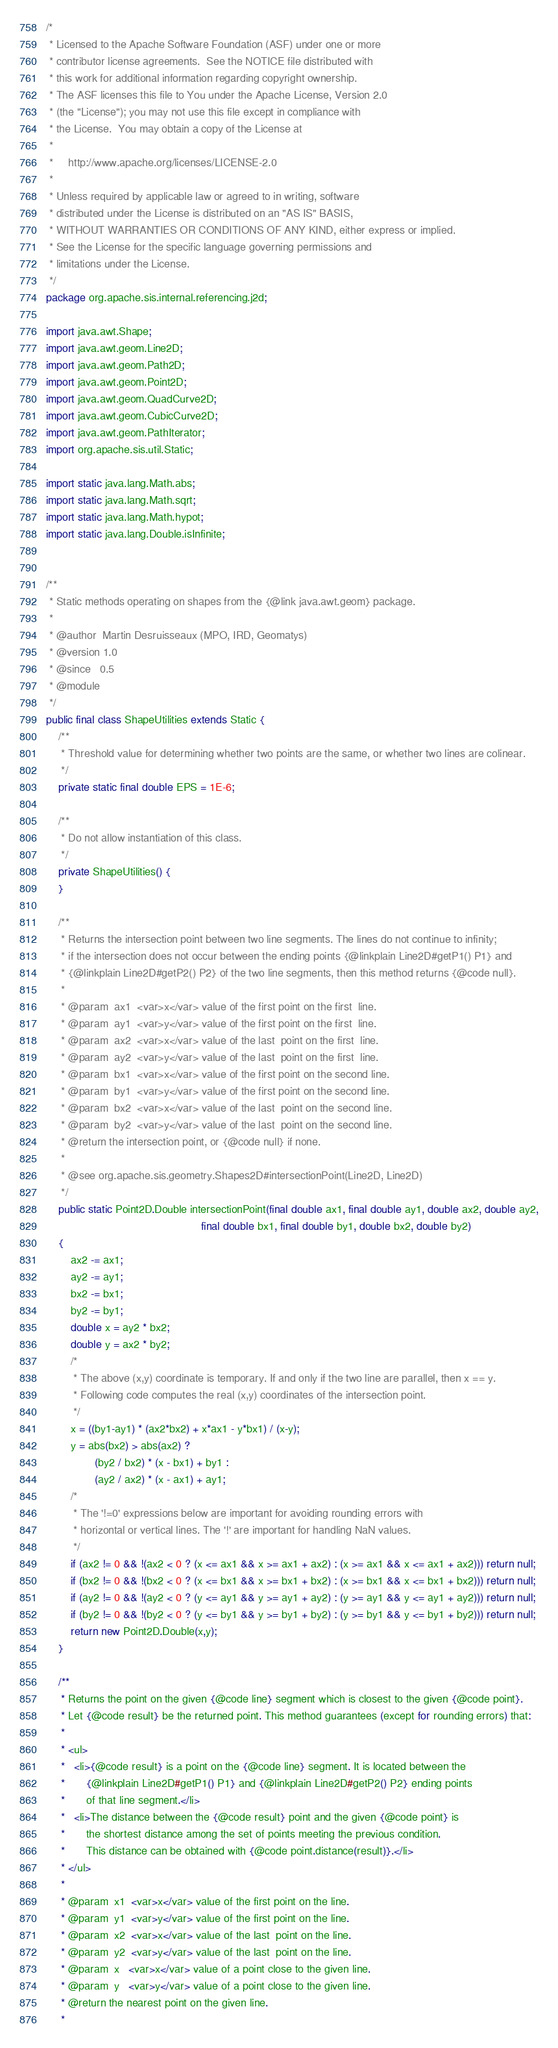<code> <loc_0><loc_0><loc_500><loc_500><_Java_>/*
 * Licensed to the Apache Software Foundation (ASF) under one or more
 * contributor license agreements.  See the NOTICE file distributed with
 * this work for additional information regarding copyright ownership.
 * The ASF licenses this file to You under the Apache License, Version 2.0
 * (the "License"); you may not use this file except in compliance with
 * the License.  You may obtain a copy of the License at
 *
 *     http://www.apache.org/licenses/LICENSE-2.0
 *
 * Unless required by applicable law or agreed to in writing, software
 * distributed under the License is distributed on an "AS IS" BASIS,
 * WITHOUT WARRANTIES OR CONDITIONS OF ANY KIND, either express or implied.
 * See the License for the specific language governing permissions and
 * limitations under the License.
 */
package org.apache.sis.internal.referencing.j2d;

import java.awt.Shape;
import java.awt.geom.Line2D;
import java.awt.geom.Path2D;
import java.awt.geom.Point2D;
import java.awt.geom.QuadCurve2D;
import java.awt.geom.CubicCurve2D;
import java.awt.geom.PathIterator;
import org.apache.sis.util.Static;

import static java.lang.Math.abs;
import static java.lang.Math.sqrt;
import static java.lang.Math.hypot;
import static java.lang.Double.isInfinite;


/**
 * Static methods operating on shapes from the {@link java.awt.geom} package.
 *
 * @author  Martin Desruisseaux (MPO, IRD, Geomatys)
 * @version 1.0
 * @since   0.5
 * @module
 */
public final class ShapeUtilities extends Static {
    /**
     * Threshold value for determining whether two points are the same, or whether two lines are colinear.
     */
    private static final double EPS = 1E-6;

    /**
     * Do not allow instantiation of this class.
     */
    private ShapeUtilities() {
    }

    /**
     * Returns the intersection point between two line segments. The lines do not continue to infinity;
     * if the intersection does not occur between the ending points {@linkplain Line2D#getP1() P1} and
     * {@linkplain Line2D#getP2() P2} of the two line segments, then this method returns {@code null}.
     *
     * @param  ax1  <var>x</var> value of the first point on the first  line.
     * @param  ay1  <var>y</var> value of the first point on the first  line.
     * @param  ax2  <var>x</var> value of the last  point on the first  line.
     * @param  ay2  <var>y</var> value of the last  point on the first  line.
     * @param  bx1  <var>x</var> value of the first point on the second line.
     * @param  by1  <var>y</var> value of the first point on the second line.
     * @param  bx2  <var>x</var> value of the last  point on the second line.
     * @param  by2  <var>y</var> value of the last  point on the second line.
     * @return the intersection point, or {@code null} if none.
     *
     * @see org.apache.sis.geometry.Shapes2D#intersectionPoint(Line2D, Line2D)
     */
    public static Point2D.Double intersectionPoint(final double ax1, final double ay1, double ax2, double ay2,
                                                   final double bx1, final double by1, double bx2, double by2)
    {
        ax2 -= ax1;
        ay2 -= ay1;
        bx2 -= bx1;
        by2 -= by1;
        double x = ay2 * bx2;
        double y = ax2 * by2;
        /*
         * The above (x,y) coordinate is temporary. If and only if the two line are parallel, then x == y.
         * Following code computes the real (x,y) coordinates of the intersection point.
         */
        x = ((by1-ay1) * (ax2*bx2) + x*ax1 - y*bx1) / (x-y);
        y = abs(bx2) > abs(ax2) ?
                (by2 / bx2) * (x - bx1) + by1 :
                (ay2 / ax2) * (x - ax1) + ay1;
        /*
         * The '!=0' expressions below are important for avoiding rounding errors with
         * horizontal or vertical lines. The '!' are important for handling NaN values.
         */
        if (ax2 != 0 && !(ax2 < 0 ? (x <= ax1 && x >= ax1 + ax2) : (x >= ax1 && x <= ax1 + ax2))) return null;
        if (bx2 != 0 && !(bx2 < 0 ? (x <= bx1 && x >= bx1 + bx2) : (x >= bx1 && x <= bx1 + bx2))) return null;
        if (ay2 != 0 && !(ay2 < 0 ? (y <= ay1 && y >= ay1 + ay2) : (y >= ay1 && y <= ay1 + ay2))) return null;
        if (by2 != 0 && !(by2 < 0 ? (y <= by1 && y >= by1 + by2) : (y >= by1 && y <= by1 + by2))) return null;
        return new Point2D.Double(x,y);
    }

    /**
     * Returns the point on the given {@code line} segment which is closest to the given {@code point}.
     * Let {@code result} be the returned point. This method guarantees (except for rounding errors) that:
     *
     * <ul>
     *   <li>{@code result} is a point on the {@code line} segment. It is located between the
     *       {@linkplain Line2D#getP1() P1} and {@linkplain Line2D#getP2() P2} ending points
     *       of that line segment.</li>
     *   <li>The distance between the {@code result} point and the given {@code point} is
     *       the shortest distance among the set of points meeting the previous condition.
     *       This distance can be obtained with {@code point.distance(result)}.</li>
     * </ul>
     *
     * @param  x1  <var>x</var> value of the first point on the line.
     * @param  y1  <var>y</var> value of the first point on the line.
     * @param  x2  <var>x</var> value of the last  point on the line.
     * @param  y2  <var>y</var> value of the last  point on the line.
     * @param  x   <var>x</var> value of a point close to the given line.
     * @param  y   <var>y</var> value of a point close to the given line.
     * @return the nearest point on the given line.
     *</code> 